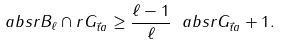Convert formula to latex. <formula><loc_0><loc_0><loc_500><loc_500>\ a b s { r { B } _ { \ell } \cap r { G } _ { \vec { t } { a } } } \geq \frac { \ell - 1 } { \ell } \ a b s { r { G } _ { \vec { t } { a } } } + 1 .</formula> 